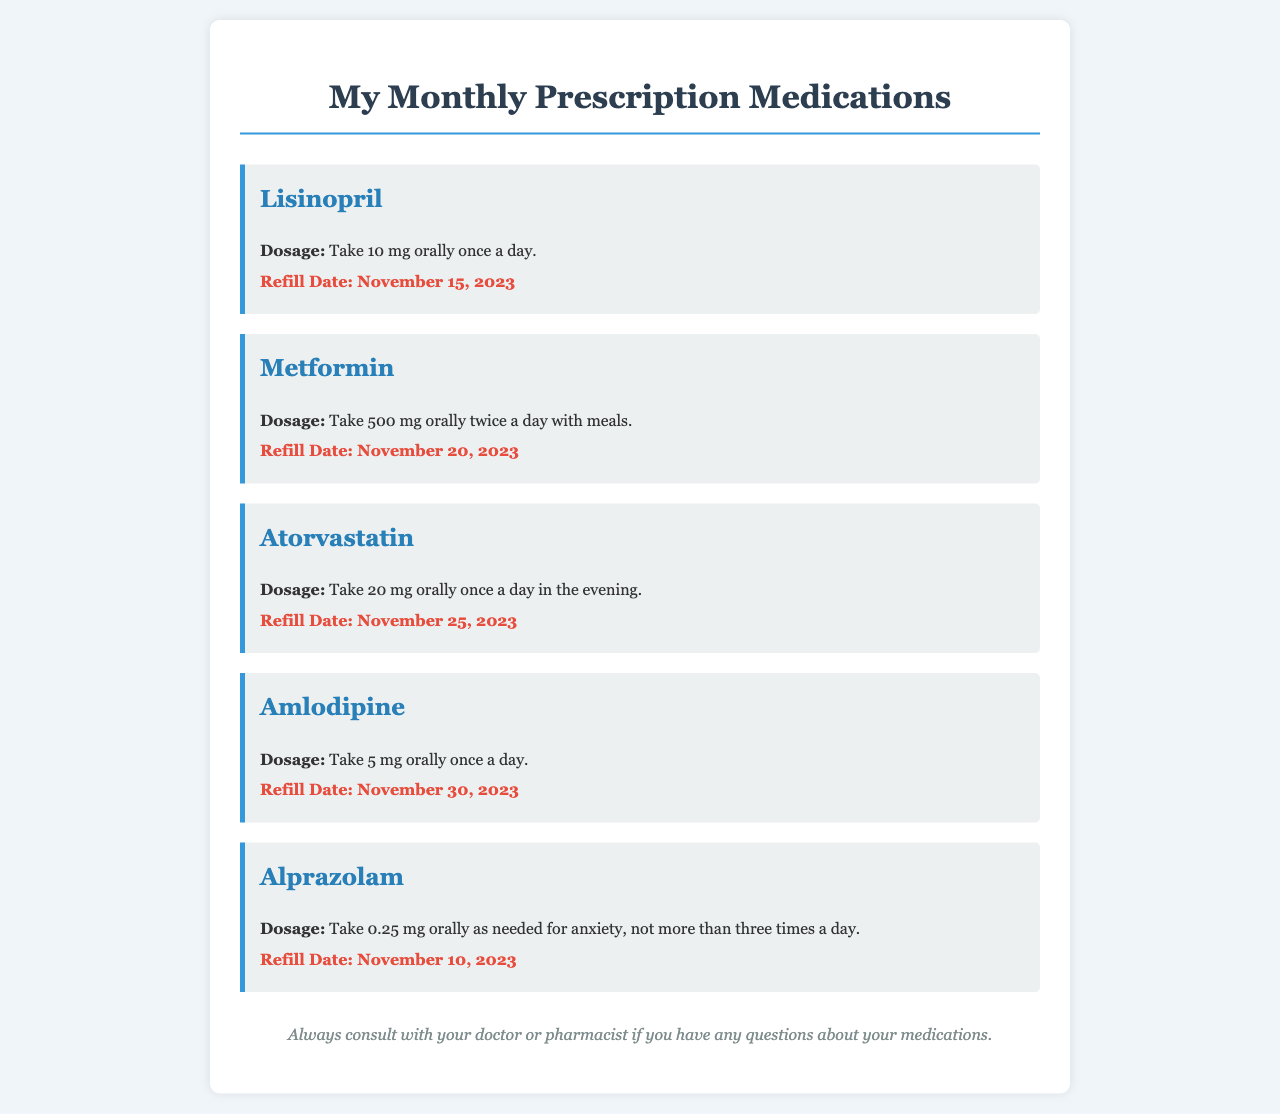What is the dosage for Lisinopril? The dosage for Lisinopril is specified in the document as "Take 10 mg orally once a day."
Answer: Take 10 mg orally once a day What is the refill date for Metformin? The refill date for Metformin is mentioned as "November 20, 2023."
Answer: November 20, 2023 How many times a day can Alprazolam be taken? The document states that Alprazolam can be taken "not more than three times a day."
Answer: Not more than three times a day What is the dosage for Amlodipine? The dosage for Amlodipine is listed as "Take 5 mg orally once a day."
Answer: Take 5 mg orally once a day Which medication should be taken in the evening? The document notes that Atorvastatin should be taken "once a day in the evening."
Answer: Atorvastatin What is the maximum dosage for Alprazolam? The maximum dosage for Alprazolam according to the document is "0.25 mg as needed" up to three times a day.
Answer: 0.25 mg as needed, up to three times a day Which two medications have refill dates in the middle of November? The refill dates for Alprazolam and Metformin fall in the middle of November, specifically November 10 and November 20, respectively.
Answer: Alprazolam and Metformin How many medications are listed in the document? The document lists a total of five medications.
Answer: Five medications What should you do if you have questions about your medications? The document concludes by recommending, "Always consult with your doctor or pharmacist if you have any questions about your medications."
Answer: Consult with your doctor or pharmacist 